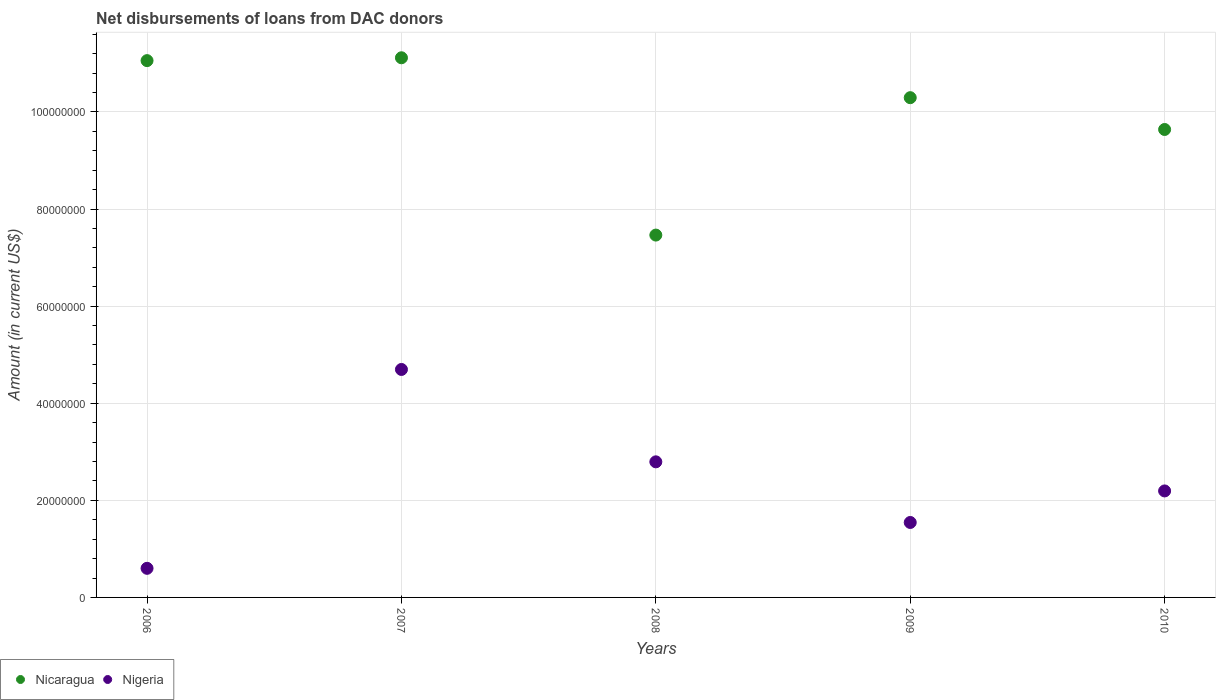How many different coloured dotlines are there?
Ensure brevity in your answer.  2. What is the amount of loans disbursed in Nicaragua in 2008?
Your response must be concise. 7.46e+07. Across all years, what is the maximum amount of loans disbursed in Nicaragua?
Ensure brevity in your answer.  1.11e+08. Across all years, what is the minimum amount of loans disbursed in Nicaragua?
Your answer should be compact. 7.46e+07. In which year was the amount of loans disbursed in Nigeria maximum?
Provide a short and direct response. 2007. In which year was the amount of loans disbursed in Nigeria minimum?
Your response must be concise. 2006. What is the total amount of loans disbursed in Nigeria in the graph?
Offer a very short reply. 1.18e+08. What is the difference between the amount of loans disbursed in Nigeria in 2006 and that in 2010?
Your response must be concise. -1.59e+07. What is the difference between the amount of loans disbursed in Nicaragua in 2010 and the amount of loans disbursed in Nigeria in 2009?
Provide a succinct answer. 8.09e+07. What is the average amount of loans disbursed in Nicaragua per year?
Provide a short and direct response. 9.91e+07. In the year 2009, what is the difference between the amount of loans disbursed in Nicaragua and amount of loans disbursed in Nigeria?
Your response must be concise. 8.75e+07. What is the ratio of the amount of loans disbursed in Nigeria in 2006 to that in 2007?
Ensure brevity in your answer.  0.13. Is the amount of loans disbursed in Nicaragua in 2007 less than that in 2009?
Provide a succinct answer. No. Is the difference between the amount of loans disbursed in Nicaragua in 2006 and 2007 greater than the difference between the amount of loans disbursed in Nigeria in 2006 and 2007?
Keep it short and to the point. Yes. What is the difference between the highest and the second highest amount of loans disbursed in Nigeria?
Give a very brief answer. 1.90e+07. What is the difference between the highest and the lowest amount of loans disbursed in Nigeria?
Ensure brevity in your answer.  4.10e+07. How many years are there in the graph?
Make the answer very short. 5. Are the values on the major ticks of Y-axis written in scientific E-notation?
Your answer should be very brief. No. Does the graph contain any zero values?
Make the answer very short. No. Does the graph contain grids?
Give a very brief answer. Yes. Where does the legend appear in the graph?
Your answer should be compact. Bottom left. How are the legend labels stacked?
Provide a short and direct response. Horizontal. What is the title of the graph?
Keep it short and to the point. Net disbursements of loans from DAC donors. Does "Kuwait" appear as one of the legend labels in the graph?
Keep it short and to the point. No. What is the label or title of the X-axis?
Your answer should be compact. Years. What is the Amount (in current US$) in Nicaragua in 2006?
Your answer should be very brief. 1.11e+08. What is the Amount (in current US$) of Nigeria in 2006?
Your answer should be compact. 6.00e+06. What is the Amount (in current US$) in Nicaragua in 2007?
Make the answer very short. 1.11e+08. What is the Amount (in current US$) in Nigeria in 2007?
Your response must be concise. 4.70e+07. What is the Amount (in current US$) in Nicaragua in 2008?
Your answer should be compact. 7.46e+07. What is the Amount (in current US$) in Nigeria in 2008?
Give a very brief answer. 2.79e+07. What is the Amount (in current US$) of Nicaragua in 2009?
Offer a terse response. 1.03e+08. What is the Amount (in current US$) of Nigeria in 2009?
Provide a succinct answer. 1.54e+07. What is the Amount (in current US$) of Nicaragua in 2010?
Make the answer very short. 9.64e+07. What is the Amount (in current US$) of Nigeria in 2010?
Your answer should be very brief. 2.19e+07. Across all years, what is the maximum Amount (in current US$) of Nicaragua?
Offer a very short reply. 1.11e+08. Across all years, what is the maximum Amount (in current US$) in Nigeria?
Offer a very short reply. 4.70e+07. Across all years, what is the minimum Amount (in current US$) of Nicaragua?
Keep it short and to the point. 7.46e+07. Across all years, what is the minimum Amount (in current US$) in Nigeria?
Provide a succinct answer. 6.00e+06. What is the total Amount (in current US$) of Nicaragua in the graph?
Offer a terse response. 4.96e+08. What is the total Amount (in current US$) of Nigeria in the graph?
Your answer should be very brief. 1.18e+08. What is the difference between the Amount (in current US$) in Nicaragua in 2006 and that in 2007?
Offer a very short reply. -5.87e+05. What is the difference between the Amount (in current US$) of Nigeria in 2006 and that in 2007?
Provide a succinct answer. -4.10e+07. What is the difference between the Amount (in current US$) of Nicaragua in 2006 and that in 2008?
Give a very brief answer. 3.59e+07. What is the difference between the Amount (in current US$) in Nigeria in 2006 and that in 2008?
Your response must be concise. -2.19e+07. What is the difference between the Amount (in current US$) in Nicaragua in 2006 and that in 2009?
Ensure brevity in your answer.  7.63e+06. What is the difference between the Amount (in current US$) of Nigeria in 2006 and that in 2009?
Your response must be concise. -9.44e+06. What is the difference between the Amount (in current US$) in Nicaragua in 2006 and that in 2010?
Offer a terse response. 1.42e+07. What is the difference between the Amount (in current US$) in Nigeria in 2006 and that in 2010?
Offer a very short reply. -1.59e+07. What is the difference between the Amount (in current US$) of Nicaragua in 2007 and that in 2008?
Ensure brevity in your answer.  3.65e+07. What is the difference between the Amount (in current US$) in Nigeria in 2007 and that in 2008?
Make the answer very short. 1.90e+07. What is the difference between the Amount (in current US$) of Nicaragua in 2007 and that in 2009?
Your answer should be very brief. 8.22e+06. What is the difference between the Amount (in current US$) in Nigeria in 2007 and that in 2009?
Your response must be concise. 3.15e+07. What is the difference between the Amount (in current US$) in Nicaragua in 2007 and that in 2010?
Offer a terse response. 1.48e+07. What is the difference between the Amount (in current US$) in Nigeria in 2007 and that in 2010?
Offer a very short reply. 2.50e+07. What is the difference between the Amount (in current US$) in Nicaragua in 2008 and that in 2009?
Keep it short and to the point. -2.83e+07. What is the difference between the Amount (in current US$) of Nigeria in 2008 and that in 2009?
Give a very brief answer. 1.25e+07. What is the difference between the Amount (in current US$) in Nicaragua in 2008 and that in 2010?
Your response must be concise. -2.18e+07. What is the difference between the Amount (in current US$) of Nigeria in 2008 and that in 2010?
Make the answer very short. 5.99e+06. What is the difference between the Amount (in current US$) in Nicaragua in 2009 and that in 2010?
Provide a succinct answer. 6.55e+06. What is the difference between the Amount (in current US$) of Nigeria in 2009 and that in 2010?
Your answer should be compact. -6.50e+06. What is the difference between the Amount (in current US$) of Nicaragua in 2006 and the Amount (in current US$) of Nigeria in 2007?
Ensure brevity in your answer.  6.36e+07. What is the difference between the Amount (in current US$) in Nicaragua in 2006 and the Amount (in current US$) in Nigeria in 2008?
Provide a succinct answer. 8.26e+07. What is the difference between the Amount (in current US$) in Nicaragua in 2006 and the Amount (in current US$) in Nigeria in 2009?
Offer a terse response. 9.51e+07. What is the difference between the Amount (in current US$) of Nicaragua in 2006 and the Amount (in current US$) of Nigeria in 2010?
Your answer should be compact. 8.86e+07. What is the difference between the Amount (in current US$) of Nicaragua in 2007 and the Amount (in current US$) of Nigeria in 2008?
Give a very brief answer. 8.32e+07. What is the difference between the Amount (in current US$) of Nicaragua in 2007 and the Amount (in current US$) of Nigeria in 2009?
Ensure brevity in your answer.  9.57e+07. What is the difference between the Amount (in current US$) of Nicaragua in 2007 and the Amount (in current US$) of Nigeria in 2010?
Offer a very short reply. 8.92e+07. What is the difference between the Amount (in current US$) in Nicaragua in 2008 and the Amount (in current US$) in Nigeria in 2009?
Provide a short and direct response. 5.92e+07. What is the difference between the Amount (in current US$) in Nicaragua in 2008 and the Amount (in current US$) in Nigeria in 2010?
Provide a short and direct response. 5.27e+07. What is the difference between the Amount (in current US$) in Nicaragua in 2009 and the Amount (in current US$) in Nigeria in 2010?
Offer a terse response. 8.10e+07. What is the average Amount (in current US$) in Nicaragua per year?
Give a very brief answer. 9.91e+07. What is the average Amount (in current US$) of Nigeria per year?
Make the answer very short. 2.37e+07. In the year 2006, what is the difference between the Amount (in current US$) of Nicaragua and Amount (in current US$) of Nigeria?
Provide a short and direct response. 1.05e+08. In the year 2007, what is the difference between the Amount (in current US$) in Nicaragua and Amount (in current US$) in Nigeria?
Provide a short and direct response. 6.42e+07. In the year 2008, what is the difference between the Amount (in current US$) in Nicaragua and Amount (in current US$) in Nigeria?
Make the answer very short. 4.67e+07. In the year 2009, what is the difference between the Amount (in current US$) in Nicaragua and Amount (in current US$) in Nigeria?
Ensure brevity in your answer.  8.75e+07. In the year 2010, what is the difference between the Amount (in current US$) in Nicaragua and Amount (in current US$) in Nigeria?
Your answer should be compact. 7.44e+07. What is the ratio of the Amount (in current US$) in Nigeria in 2006 to that in 2007?
Keep it short and to the point. 0.13. What is the ratio of the Amount (in current US$) of Nicaragua in 2006 to that in 2008?
Your answer should be compact. 1.48. What is the ratio of the Amount (in current US$) in Nigeria in 2006 to that in 2008?
Your response must be concise. 0.21. What is the ratio of the Amount (in current US$) in Nicaragua in 2006 to that in 2009?
Give a very brief answer. 1.07. What is the ratio of the Amount (in current US$) of Nigeria in 2006 to that in 2009?
Your answer should be very brief. 0.39. What is the ratio of the Amount (in current US$) in Nicaragua in 2006 to that in 2010?
Your response must be concise. 1.15. What is the ratio of the Amount (in current US$) of Nigeria in 2006 to that in 2010?
Your response must be concise. 0.27. What is the ratio of the Amount (in current US$) of Nicaragua in 2007 to that in 2008?
Keep it short and to the point. 1.49. What is the ratio of the Amount (in current US$) in Nigeria in 2007 to that in 2008?
Make the answer very short. 1.68. What is the ratio of the Amount (in current US$) in Nicaragua in 2007 to that in 2009?
Keep it short and to the point. 1.08. What is the ratio of the Amount (in current US$) in Nigeria in 2007 to that in 2009?
Ensure brevity in your answer.  3.04. What is the ratio of the Amount (in current US$) in Nicaragua in 2007 to that in 2010?
Provide a succinct answer. 1.15. What is the ratio of the Amount (in current US$) in Nigeria in 2007 to that in 2010?
Make the answer very short. 2.14. What is the ratio of the Amount (in current US$) in Nicaragua in 2008 to that in 2009?
Offer a terse response. 0.73. What is the ratio of the Amount (in current US$) of Nigeria in 2008 to that in 2009?
Your response must be concise. 1.81. What is the ratio of the Amount (in current US$) in Nicaragua in 2008 to that in 2010?
Keep it short and to the point. 0.77. What is the ratio of the Amount (in current US$) in Nigeria in 2008 to that in 2010?
Ensure brevity in your answer.  1.27. What is the ratio of the Amount (in current US$) in Nicaragua in 2009 to that in 2010?
Your response must be concise. 1.07. What is the ratio of the Amount (in current US$) of Nigeria in 2009 to that in 2010?
Provide a succinct answer. 0.7. What is the difference between the highest and the second highest Amount (in current US$) in Nicaragua?
Provide a succinct answer. 5.87e+05. What is the difference between the highest and the second highest Amount (in current US$) in Nigeria?
Your answer should be compact. 1.90e+07. What is the difference between the highest and the lowest Amount (in current US$) in Nicaragua?
Give a very brief answer. 3.65e+07. What is the difference between the highest and the lowest Amount (in current US$) of Nigeria?
Offer a terse response. 4.10e+07. 